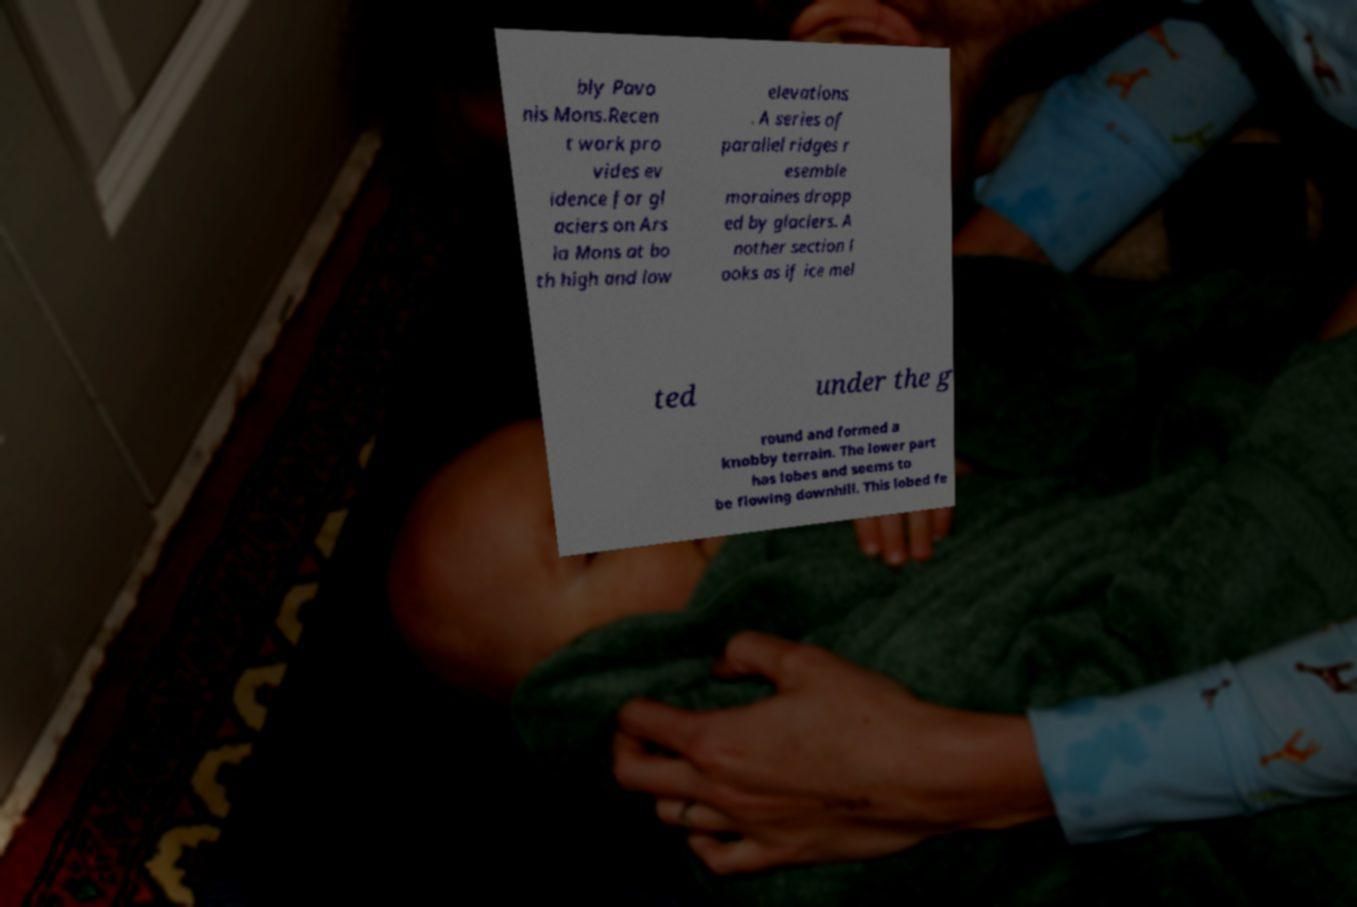What messages or text are displayed in this image? I need them in a readable, typed format. bly Pavo nis Mons.Recen t work pro vides ev idence for gl aciers on Ars ia Mons at bo th high and low elevations . A series of parallel ridges r esemble moraines dropp ed by glaciers. A nother section l ooks as if ice mel ted under the g round and formed a knobby terrain. The lower part has lobes and seems to be flowing downhill. This lobed fe 